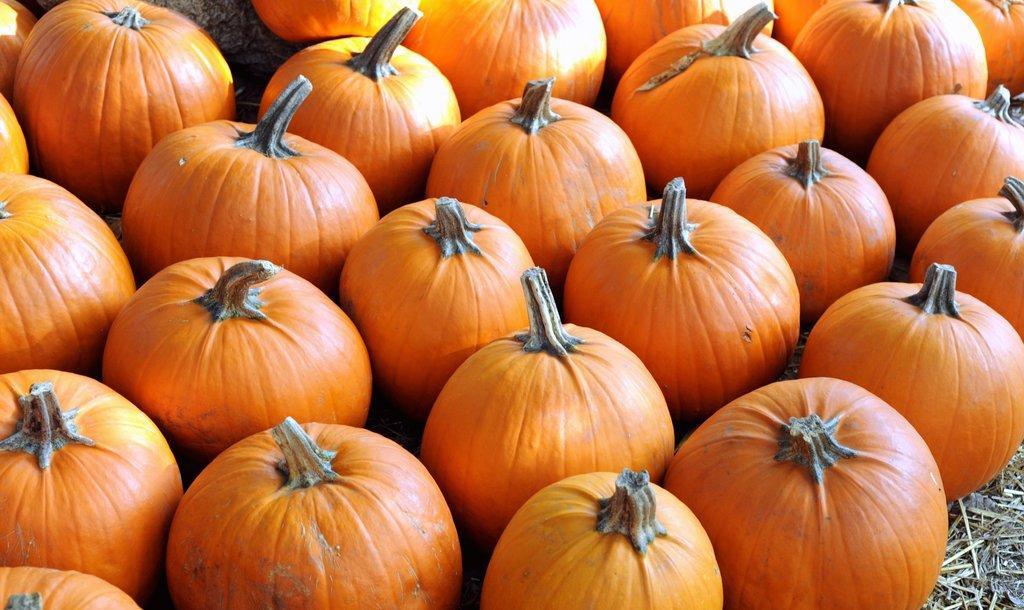Describe this image in one or two sentences. In this image there are so many pumpkins one beside the other in the line. 